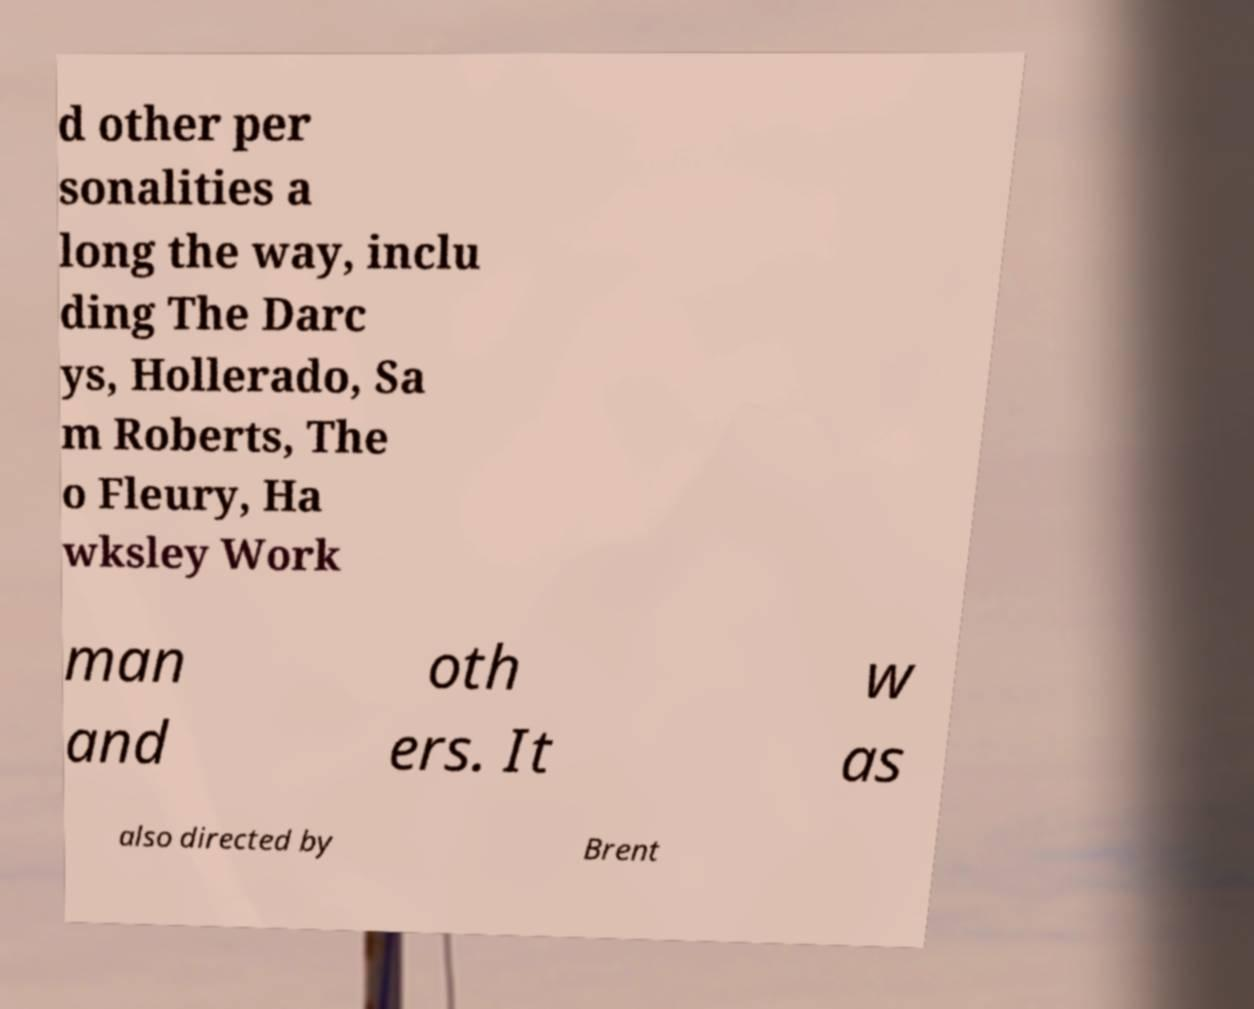I need the written content from this picture converted into text. Can you do that? d other per sonalities a long the way, inclu ding The Darc ys, Hollerado, Sa m Roberts, The o Fleury, Ha wksley Work man and oth ers. It w as also directed by Brent 